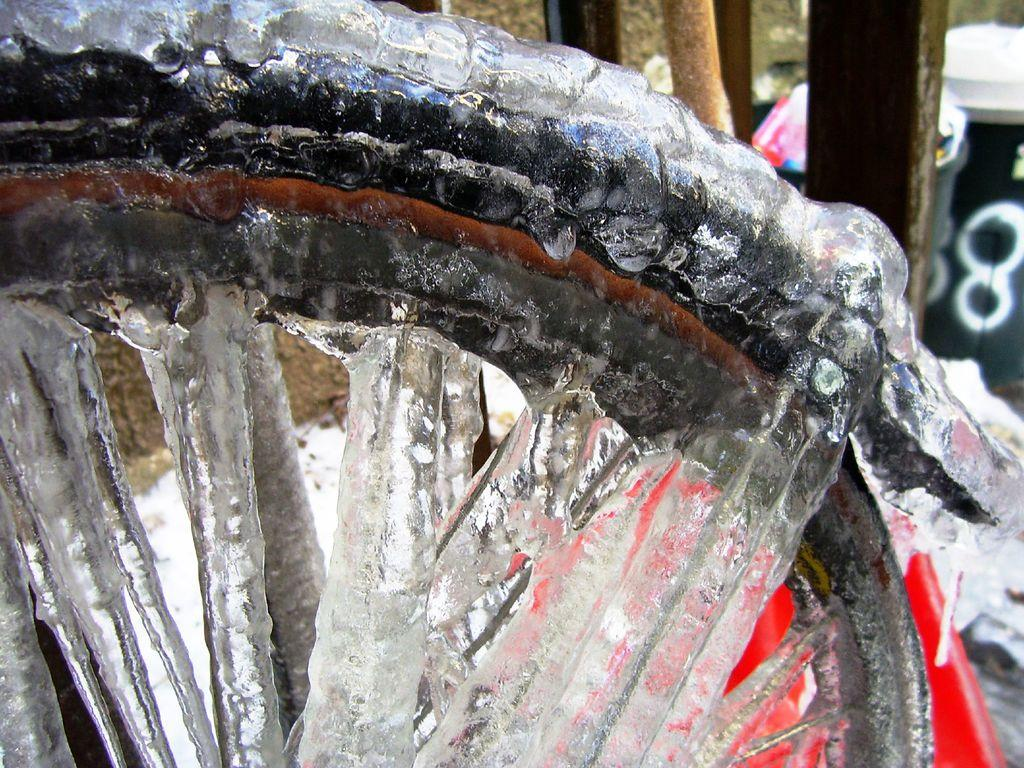What is the main object on the left side of the image? There is a bicycle's wheel on the left side of the image. What is covering the wheel in the image? The wheel is covered with ice. Can you describe any other objects visible in the image? There are other objects visible in the background of the image, but their specific details are not mentioned in the provided facts. What is your sister's work schedule for the week? There is no mention of a sister or work schedule in the image or the provided facts, so this question cannot be answered. 